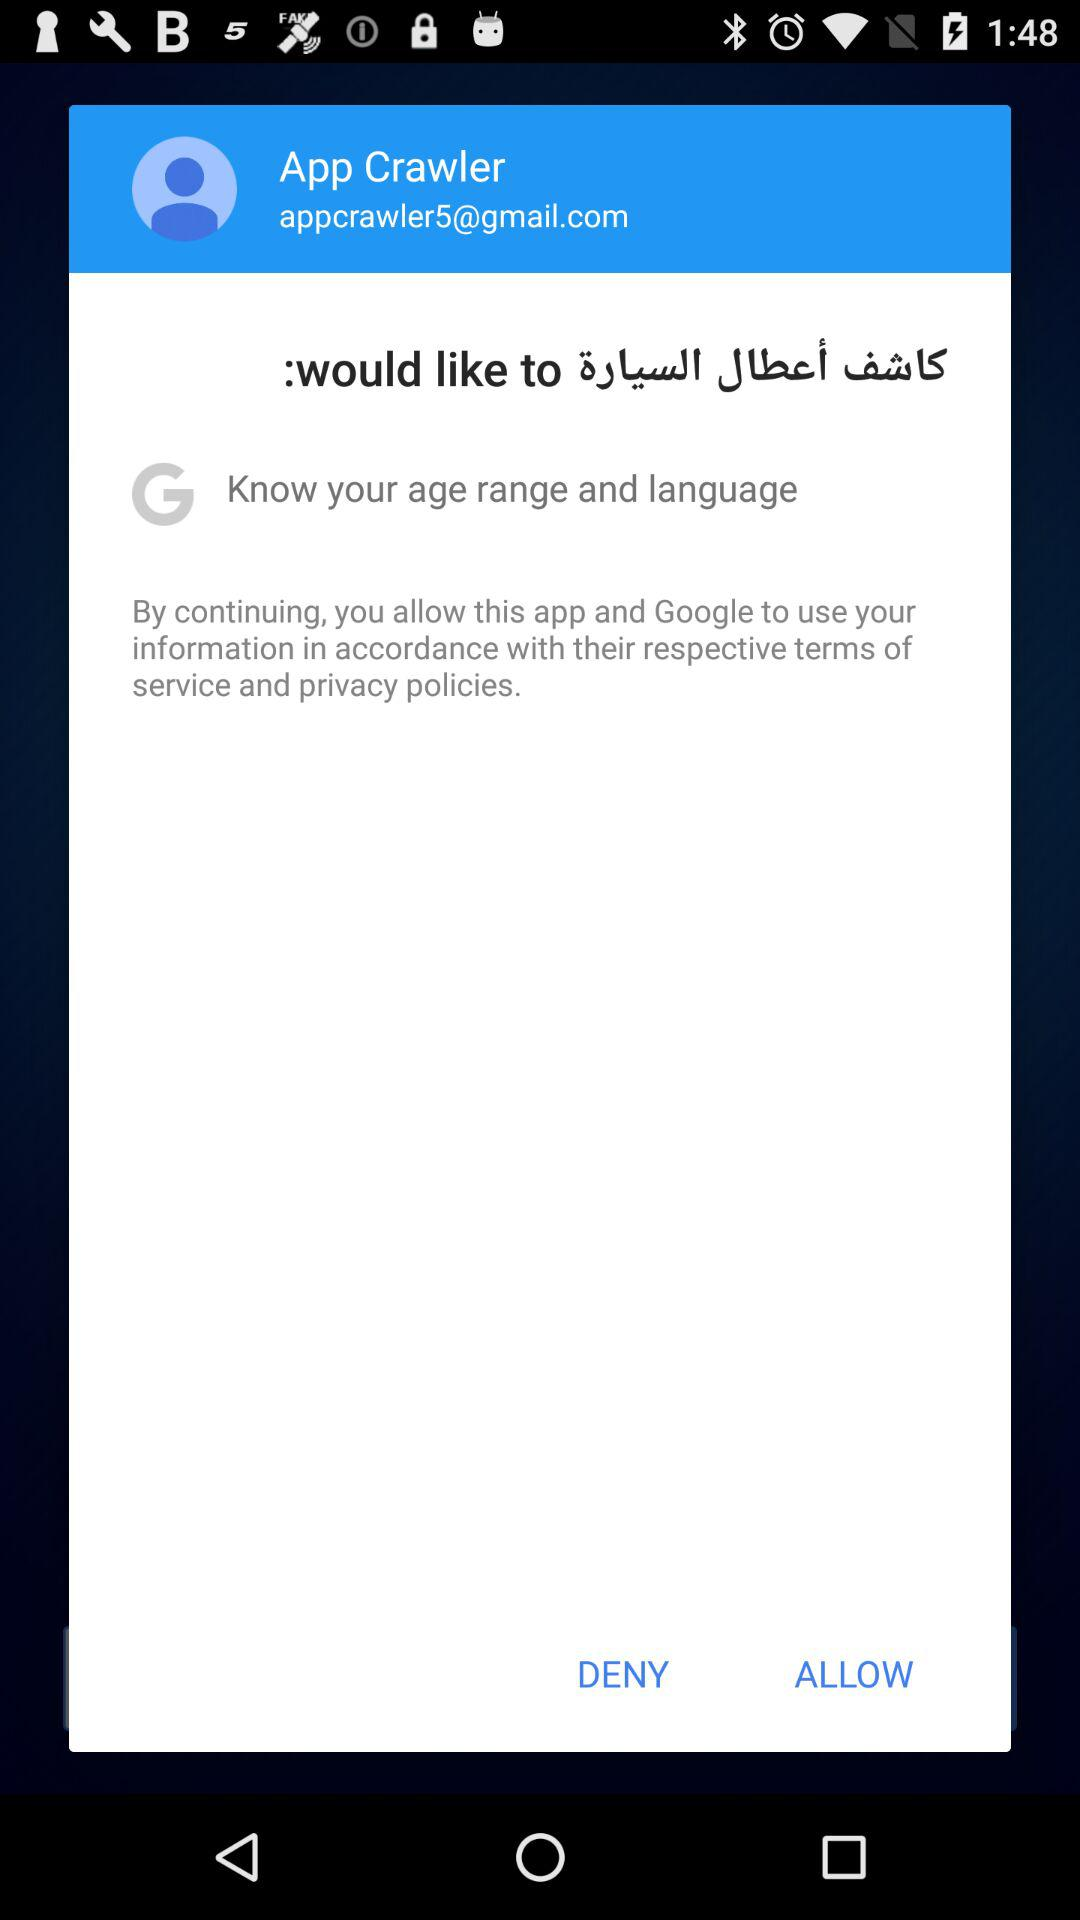What is the age range of the user?
When the provided information is insufficient, respond with <no answer>. <no answer> 